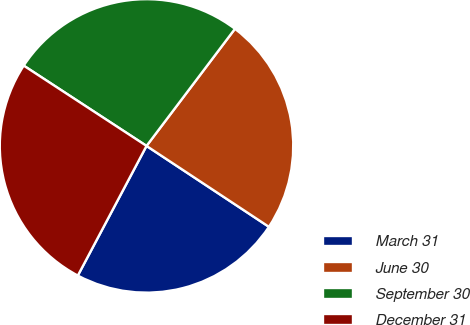Convert chart to OTSL. <chart><loc_0><loc_0><loc_500><loc_500><pie_chart><fcel>March 31<fcel>June 30<fcel>September 30<fcel>December 31<nl><fcel>23.46%<fcel>24.0%<fcel>26.08%<fcel>26.46%<nl></chart> 